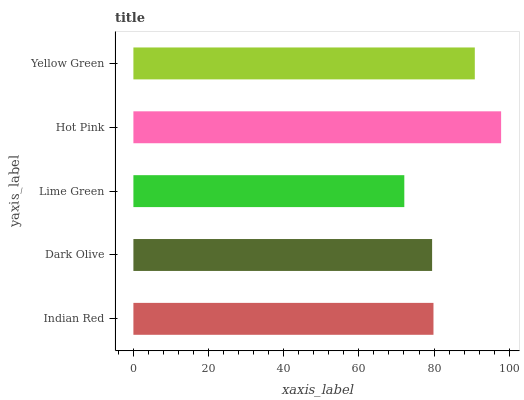Is Lime Green the minimum?
Answer yes or no. Yes. Is Hot Pink the maximum?
Answer yes or no. Yes. Is Dark Olive the minimum?
Answer yes or no. No. Is Dark Olive the maximum?
Answer yes or no. No. Is Indian Red greater than Dark Olive?
Answer yes or no. Yes. Is Dark Olive less than Indian Red?
Answer yes or no. Yes. Is Dark Olive greater than Indian Red?
Answer yes or no. No. Is Indian Red less than Dark Olive?
Answer yes or no. No. Is Indian Red the high median?
Answer yes or no. Yes. Is Indian Red the low median?
Answer yes or no. Yes. Is Lime Green the high median?
Answer yes or no. No. Is Yellow Green the low median?
Answer yes or no. No. 